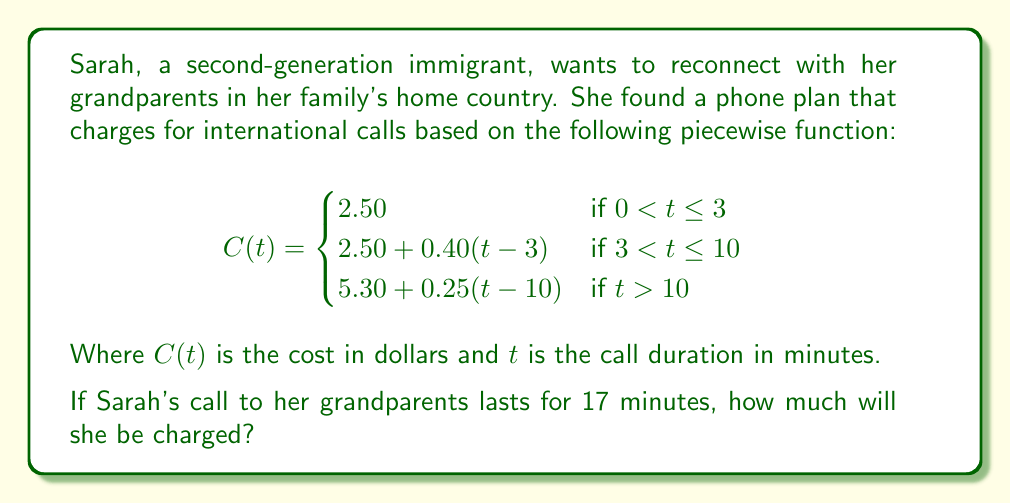Could you help me with this problem? To solve this problem, we need to determine which piece of the function applies to Sarah's 17-minute call and then calculate the cost.

1. Since $t = 17$ minutes, and $17 > 10$, we use the third piece of the function:

   $$C(t) = 5.30 + 0.25(t - 10) \text{ for } t > 10$$

2. Substitute $t = 17$ into the equation:

   $$C(17) = 5.30 + 0.25(17 - 10)$$

3. Simplify the expression inside the parentheses:

   $$C(17) = 5.30 + 0.25(7)$$

4. Multiply:

   $$C(17) = 5.30 + 1.75$$

5. Add to get the final cost:

   $$C(17) = 7.05$$

Therefore, Sarah will be charged $7.05 for her 17-minute call to her grandparents.
Answer: $7.05 